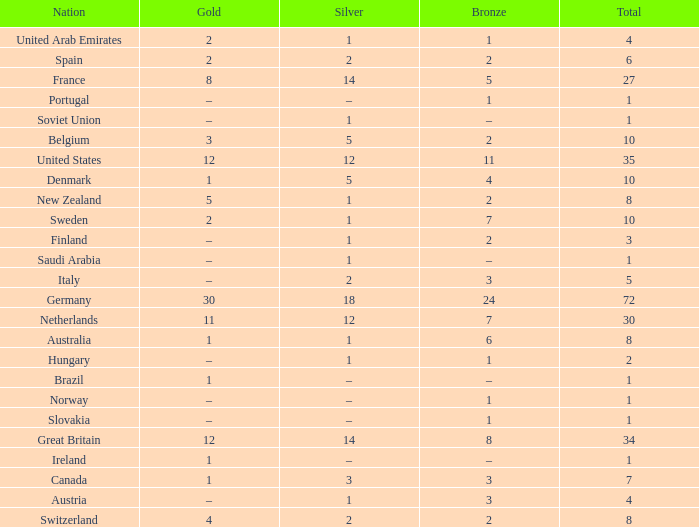What is Gold, when Silver is 5, and when Nation is Belgium? 3.0. 